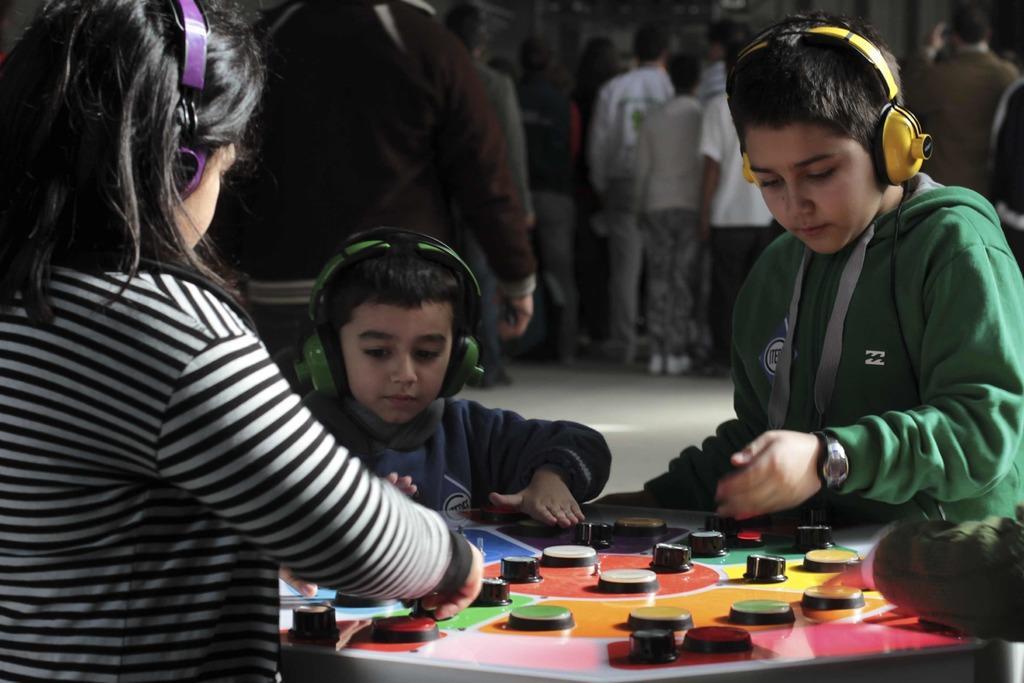Please provide a concise description of this image. In the picture there are fewer kids playing a game, they are wearing headsets and behind the kids there are many other people. 